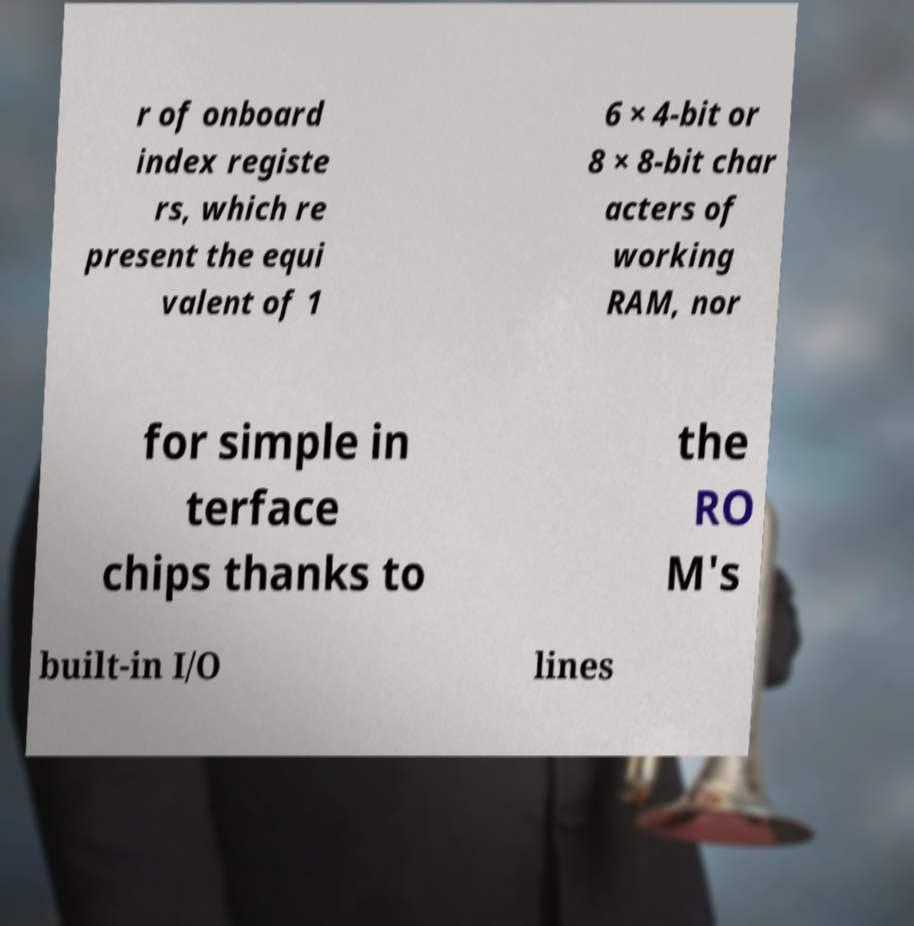Can you read and provide the text displayed in the image?This photo seems to have some interesting text. Can you extract and type it out for me? r of onboard index registe rs, which re present the equi valent of 1 6 × 4-bit or 8 × 8-bit char acters of working RAM, nor for simple in terface chips thanks to the RO M's built-in I/O lines 